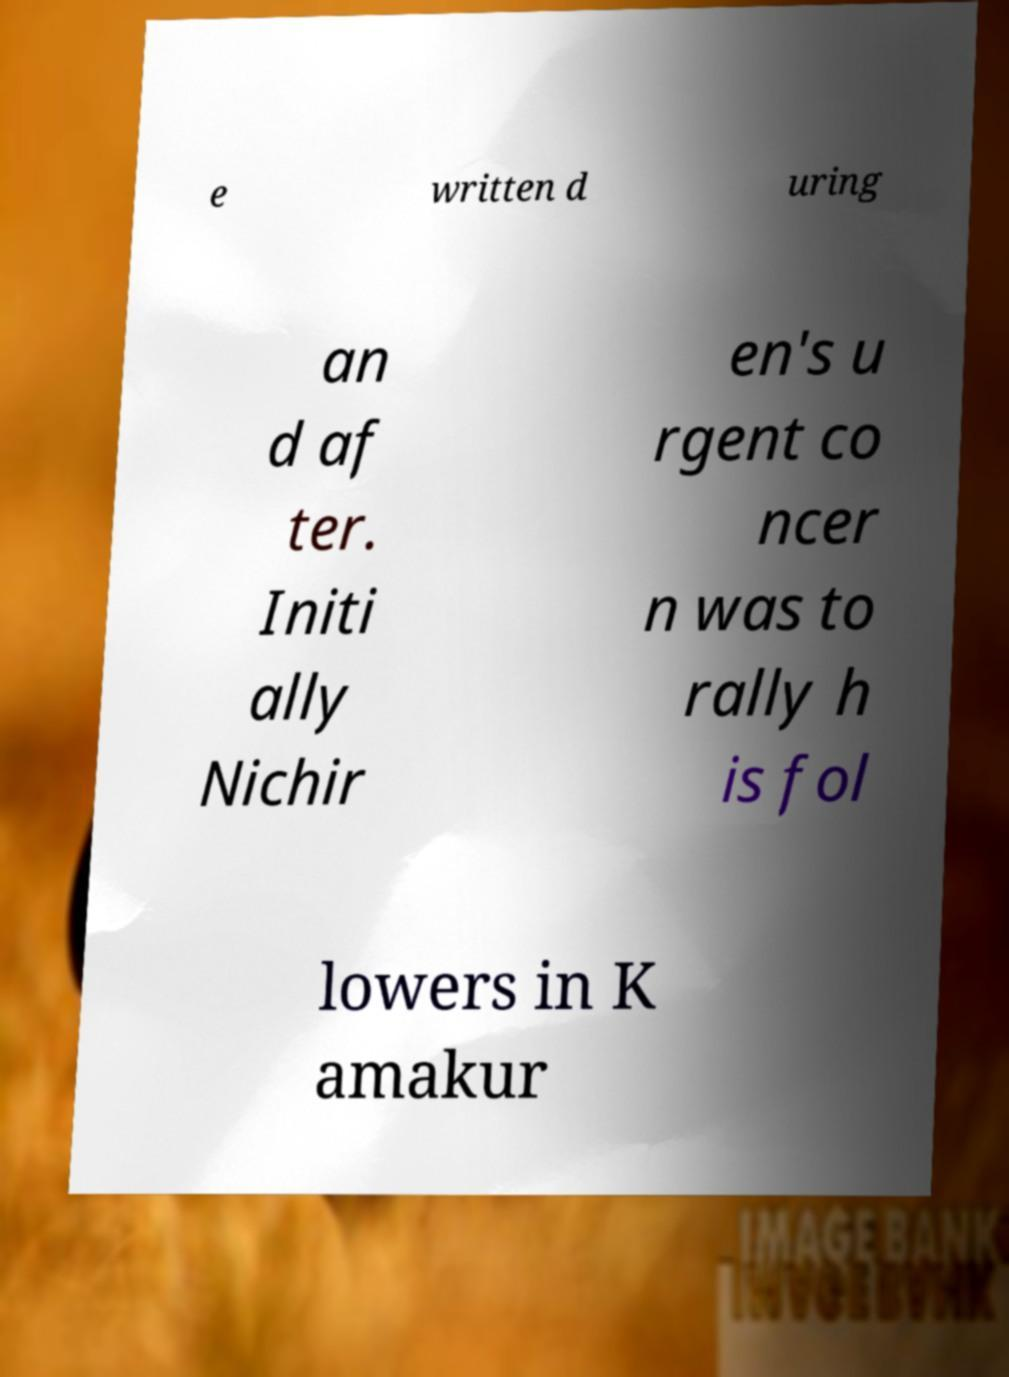Can you accurately transcribe the text from the provided image for me? e written d uring an d af ter. Initi ally Nichir en's u rgent co ncer n was to rally h is fol lowers in K amakur 